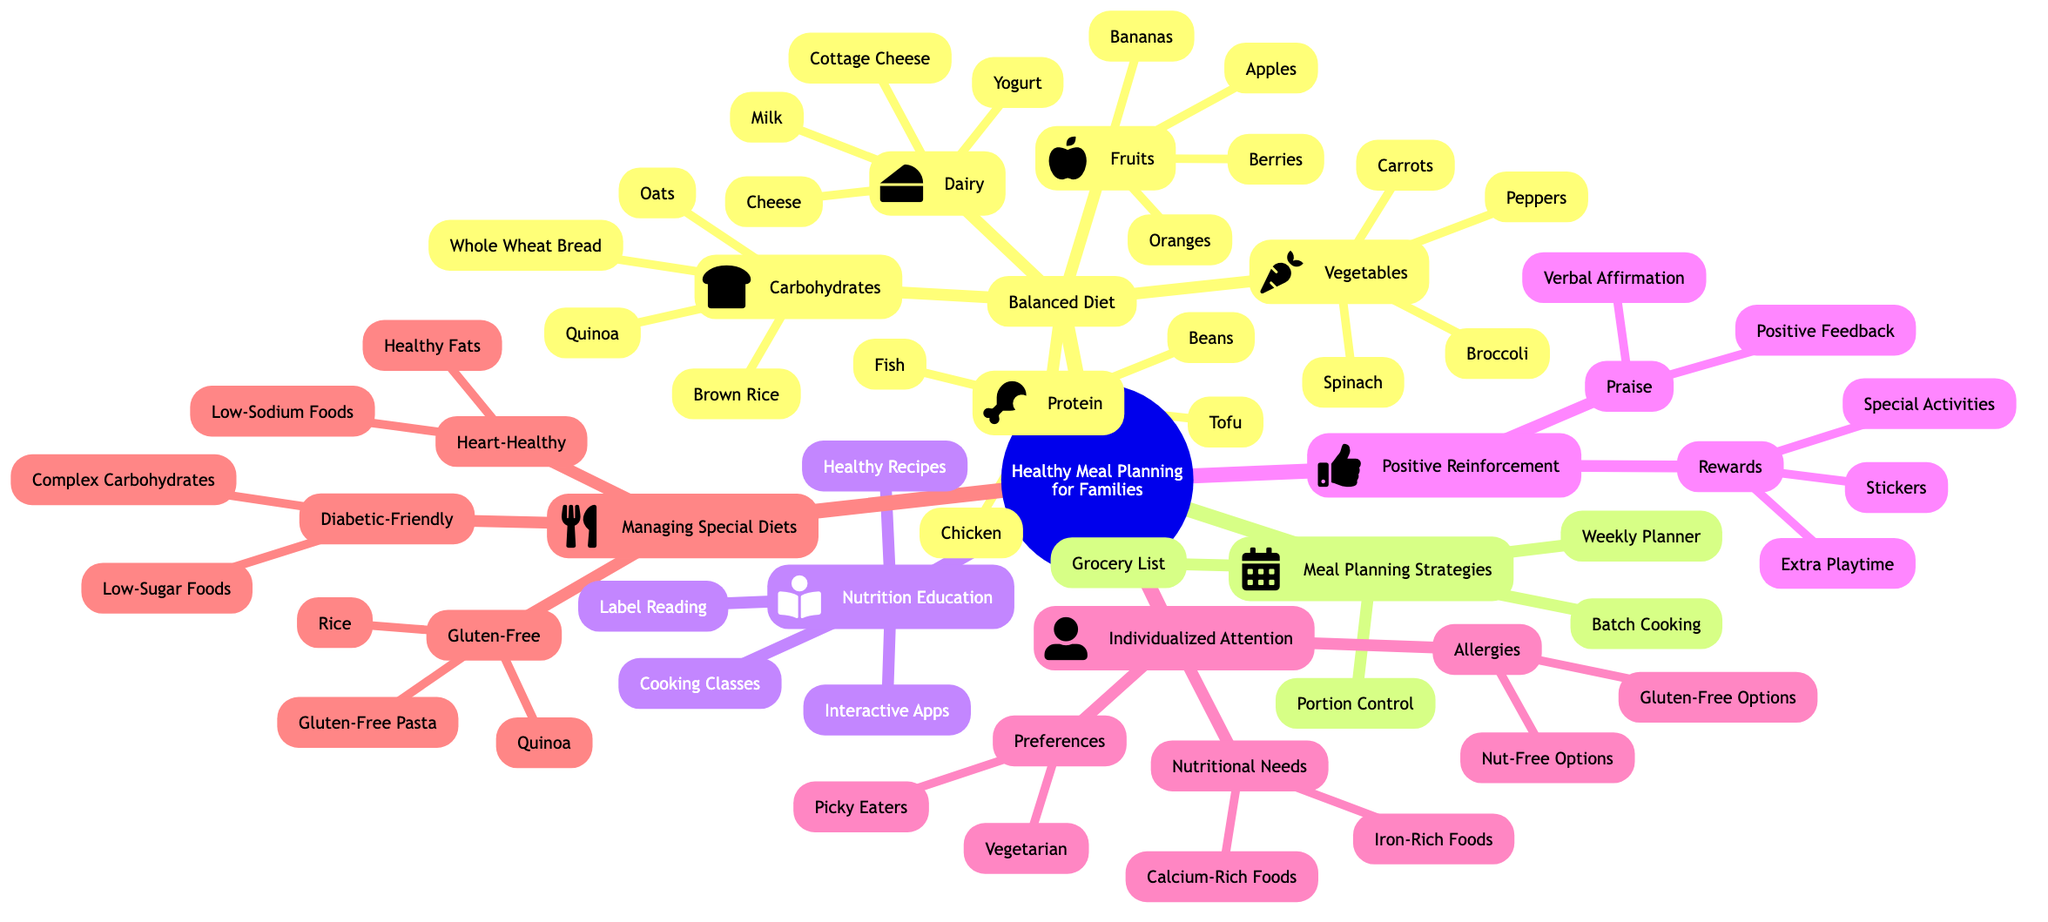What is the central concept of the diagram? The central concept, displayed at the root, is "Healthy Meal Planning for Families."
Answer: Healthy Meal Planning for Families How many elements are under the "Balanced Diet"? The "Balanced Diet" element has five sub-elements listed beneath it: Protein, Vegetables, Fruits, Carbohydrates, and Dairy.
Answer: 5 What food group is associated with "Calcium-Rich Foods"? "Calcium-Rich Foods" is listed under the "Nutritional Needs" section of the "Individualized Attention" element.
Answer: Nutritional Needs Which meal planning strategy involves preparing meals in advance? The strategy that involves preparing meals in advance is "Batch Cooking."
Answer: Batch Cooking How many different types of rewards are mentioned under "Positive Reinforcement"? There are three types of rewards mentioned: Stickers, Extra Playtime, and Special Activities.
Answer: 3 What type of diets can be managed under the "Managing Special Diets" element? The element outlines three types: Diabetic-Friendly, Heart-Healthy, and Gluten-Free.
Answer: 3 Which specific nutrient is emphasized in "Diabetic-Friendly" meals? "Diabetic-Friendly" meals emphasize "Low-Sugar Foods."
Answer: Low-Sugar Foods What is a tool used to outline meals for every day of the week? The tool used for this purpose is a "Weekly Planner."
Answer: Weekly Planner Which category do "Broccoli" and "Carrots" belong to? Both "Broccoli" and "Carrots" are included in the "Vegetables" sub-element of "Balanced Diet."
Answer: Vegetables 